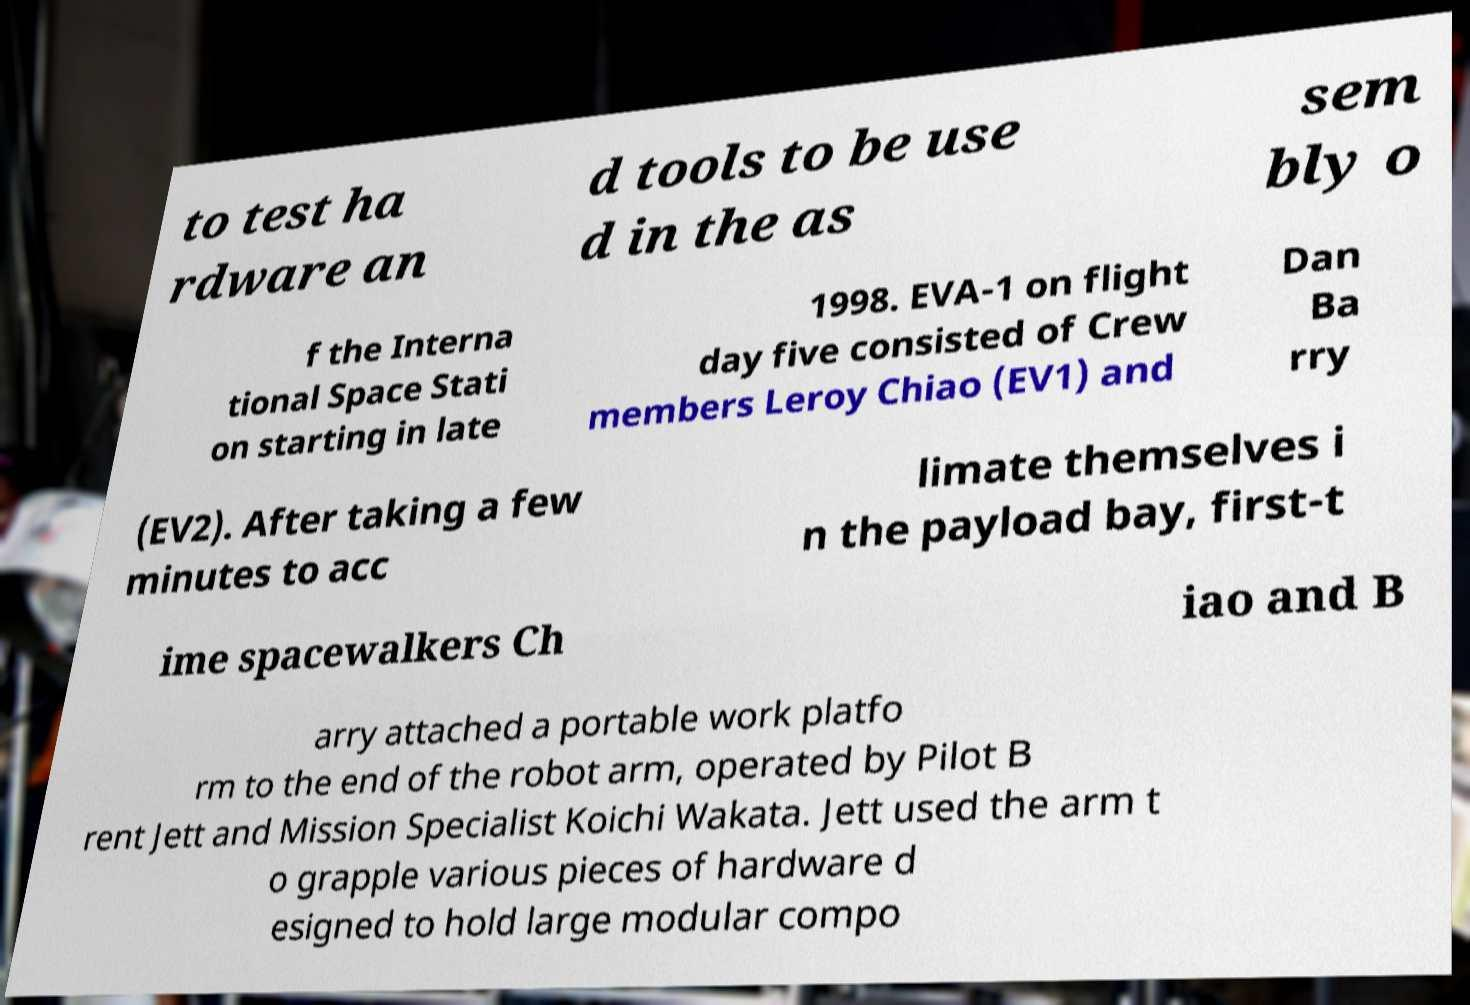Could you extract and type out the text from this image? to test ha rdware an d tools to be use d in the as sem bly o f the Interna tional Space Stati on starting in late 1998. EVA-1 on flight day five consisted of Crew members Leroy Chiao (EV1) and Dan Ba rry (EV2). After taking a few minutes to acc limate themselves i n the payload bay, first-t ime spacewalkers Ch iao and B arry attached a portable work platfo rm to the end of the robot arm, operated by Pilot B rent Jett and Mission Specialist Koichi Wakata. Jett used the arm t o grapple various pieces of hardware d esigned to hold large modular compo 